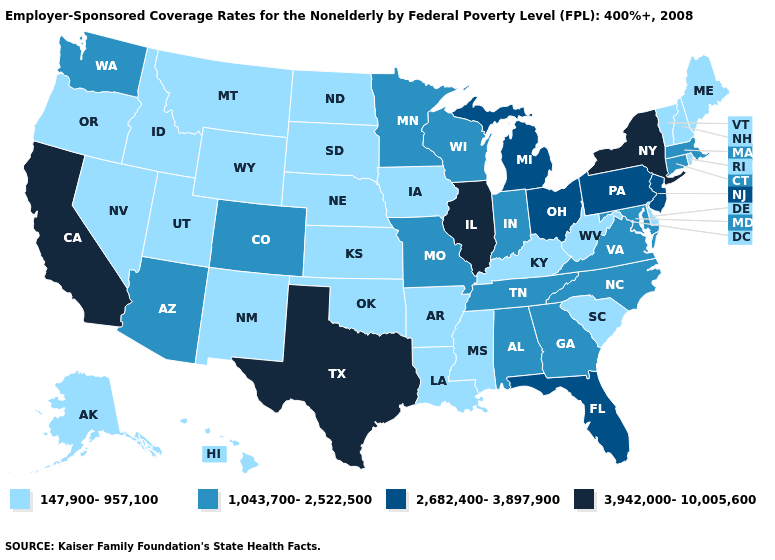How many symbols are there in the legend?
Give a very brief answer. 4. What is the value of Idaho?
Quick response, please. 147,900-957,100. Which states hav the highest value in the West?
Write a very short answer. California. What is the value of Wyoming?
Keep it brief. 147,900-957,100. Name the states that have a value in the range 1,043,700-2,522,500?
Concise answer only. Alabama, Arizona, Colorado, Connecticut, Georgia, Indiana, Maryland, Massachusetts, Minnesota, Missouri, North Carolina, Tennessee, Virginia, Washington, Wisconsin. Which states have the lowest value in the USA?
Short answer required. Alaska, Arkansas, Delaware, Hawaii, Idaho, Iowa, Kansas, Kentucky, Louisiana, Maine, Mississippi, Montana, Nebraska, Nevada, New Hampshire, New Mexico, North Dakota, Oklahoma, Oregon, Rhode Island, South Carolina, South Dakota, Utah, Vermont, West Virginia, Wyoming. Does Texas have a lower value than Montana?
Be succinct. No. What is the value of New Hampshire?
Concise answer only. 147,900-957,100. Does New York have the highest value in the Northeast?
Concise answer only. Yes. Among the states that border Nevada , which have the lowest value?
Short answer required. Idaho, Oregon, Utah. Does Utah have a higher value than Kentucky?
Concise answer only. No. What is the value of New York?
Be succinct. 3,942,000-10,005,600. Among the states that border Minnesota , which have the lowest value?
Quick response, please. Iowa, North Dakota, South Dakota. 